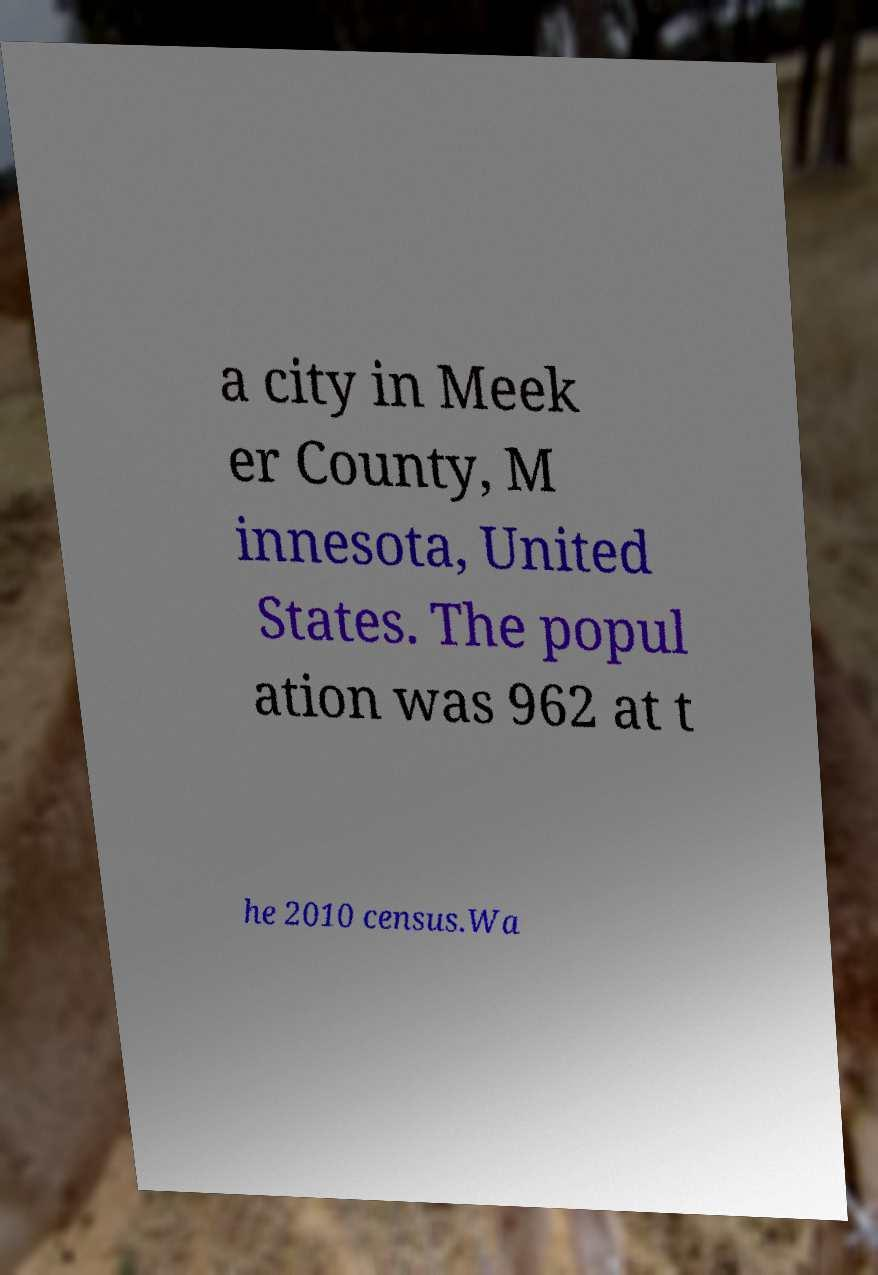Could you extract and type out the text from this image? a city in Meek er County, M innesota, United States. The popul ation was 962 at t he 2010 census.Wa 